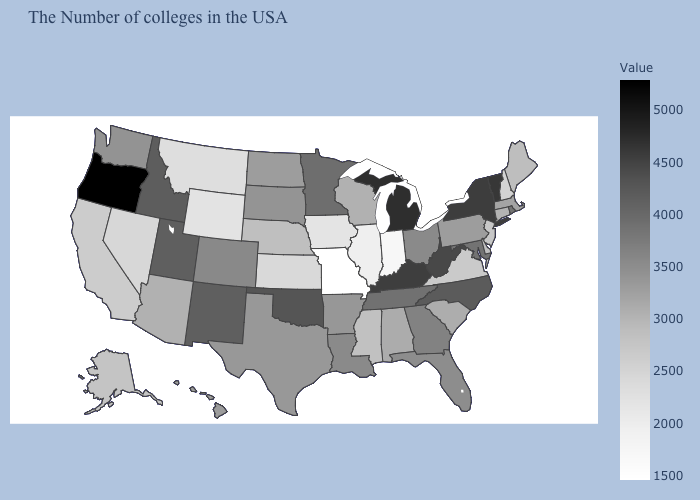Which states have the lowest value in the MidWest?
Answer briefly. Missouri. Which states have the lowest value in the USA?
Concise answer only. Missouri. Does New York have a higher value than Nebraska?
Keep it brief. Yes. Does Nevada have the lowest value in the USA?
Answer briefly. No. 